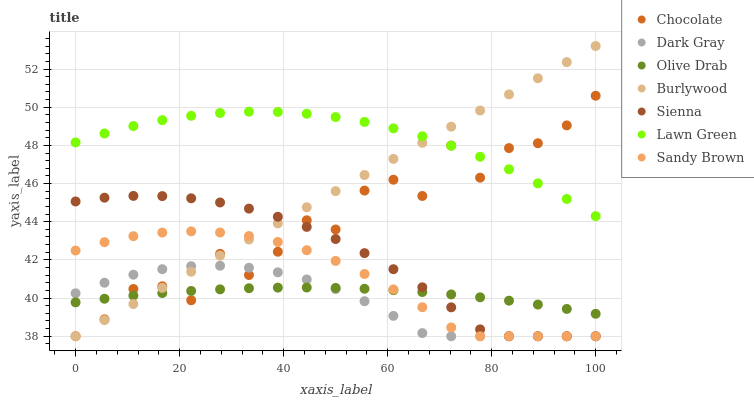Does Dark Gray have the minimum area under the curve?
Answer yes or no. Yes. Does Lawn Green have the maximum area under the curve?
Answer yes or no. Yes. Does Burlywood have the minimum area under the curve?
Answer yes or no. No. Does Burlywood have the maximum area under the curve?
Answer yes or no. No. Is Burlywood the smoothest?
Answer yes or no. Yes. Is Chocolate the roughest?
Answer yes or no. Yes. Is Lawn Green the smoothest?
Answer yes or no. No. Is Lawn Green the roughest?
Answer yes or no. No. Does Sienna have the lowest value?
Answer yes or no. Yes. Does Lawn Green have the lowest value?
Answer yes or no. No. Does Burlywood have the highest value?
Answer yes or no. Yes. Does Lawn Green have the highest value?
Answer yes or no. No. Is Sandy Brown less than Lawn Green?
Answer yes or no. Yes. Is Lawn Green greater than Dark Gray?
Answer yes or no. Yes. Does Sienna intersect Chocolate?
Answer yes or no. Yes. Is Sienna less than Chocolate?
Answer yes or no. No. Is Sienna greater than Chocolate?
Answer yes or no. No. Does Sandy Brown intersect Lawn Green?
Answer yes or no. No. 